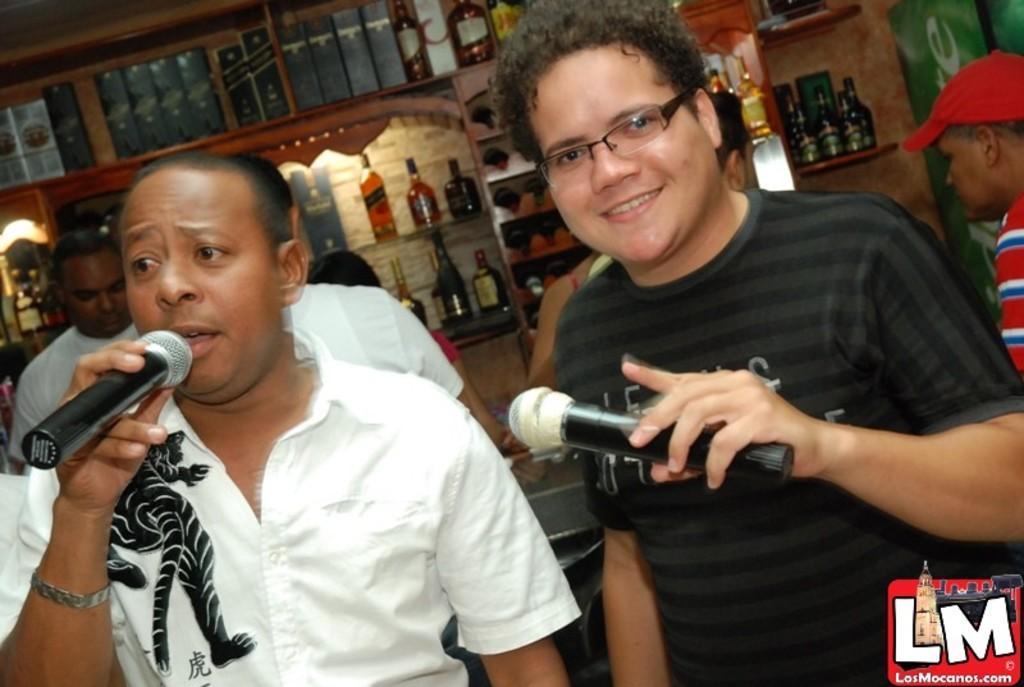Please provide a concise description of this image. A person is wearing a white shirt is holding mic and singing. Also a person wearing a black t shirt is holding a mic and smiling and wearing a spectacles. Behind them there are many bottles and cup board is there. And one person is wearing a red cap and red shirt is standing over there. 